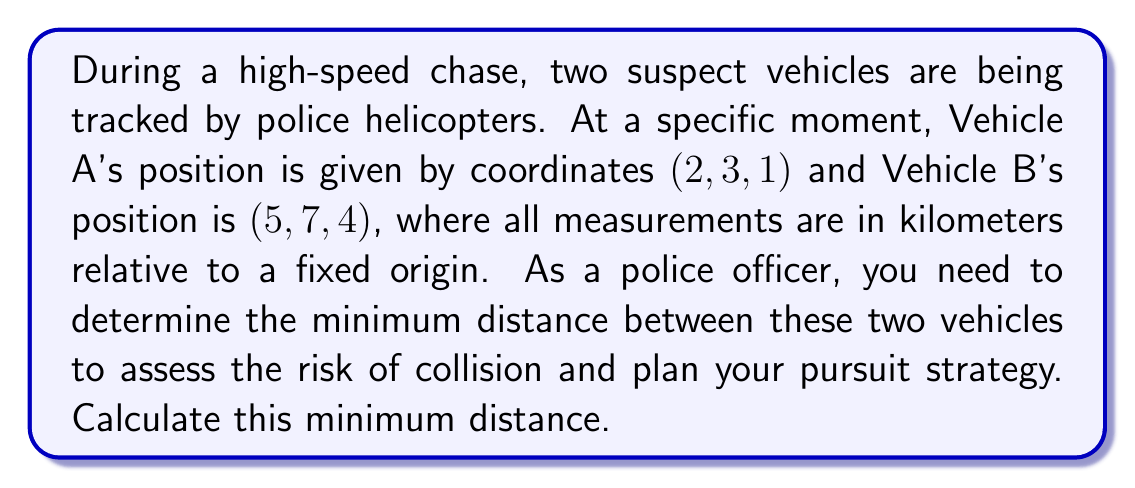Could you help me with this problem? To find the minimum distance between two points in 3D space, we can use the distance formula derived from the Pythagorean theorem in three dimensions. 

Let's denote the coordinates of Vehicle A as $(x_1, y_1, z_1) = (2, 3, 1)$ and Vehicle B as $(x_2, y_2, z_2) = (5, 7, 4)$.

The distance formula in 3D space is:

$$d = \sqrt{(x_2 - x_1)^2 + (y_2 - y_1)^2 + (z_2 - z_1)^2}$$

Let's substitute the values:

$$\begin{align}
d &= \sqrt{(5 - 2)^2 + (7 - 3)^2 + (4 - 1)^2} \\
&= \sqrt{3^2 + 4^2 + 3^2} \\
&= \sqrt{9 + 16 + 9} \\
&= \sqrt{34} \\
&\approx 5.83 \text{ km}
\end{align}$$

This distance represents the length of the straight line connecting the two vehicles in 3D space, which is the minimum possible distance between them.

[asy]
import three;

currentprojection=perspective(6,3,2);
size(200);

draw(O--5X,gray+dashed);
draw(O--7Y,gray+dashed);
draw(O--4Z,gray+dashed);

dot("A (2,3,1)",(2,3,1),NE);
dot("B (5,7,4)",(5,7,4),NE);

draw((2,3,1)--(5,7,4),red,Arrow3);
[/asy]
Answer: The minimum distance between the two vehicles is $\sqrt{34} \approx 5.83$ kilometers. 